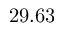Convert formula to latex. <formula><loc_0><loc_0><loc_500><loc_500>2 9 . 6 3</formula> 